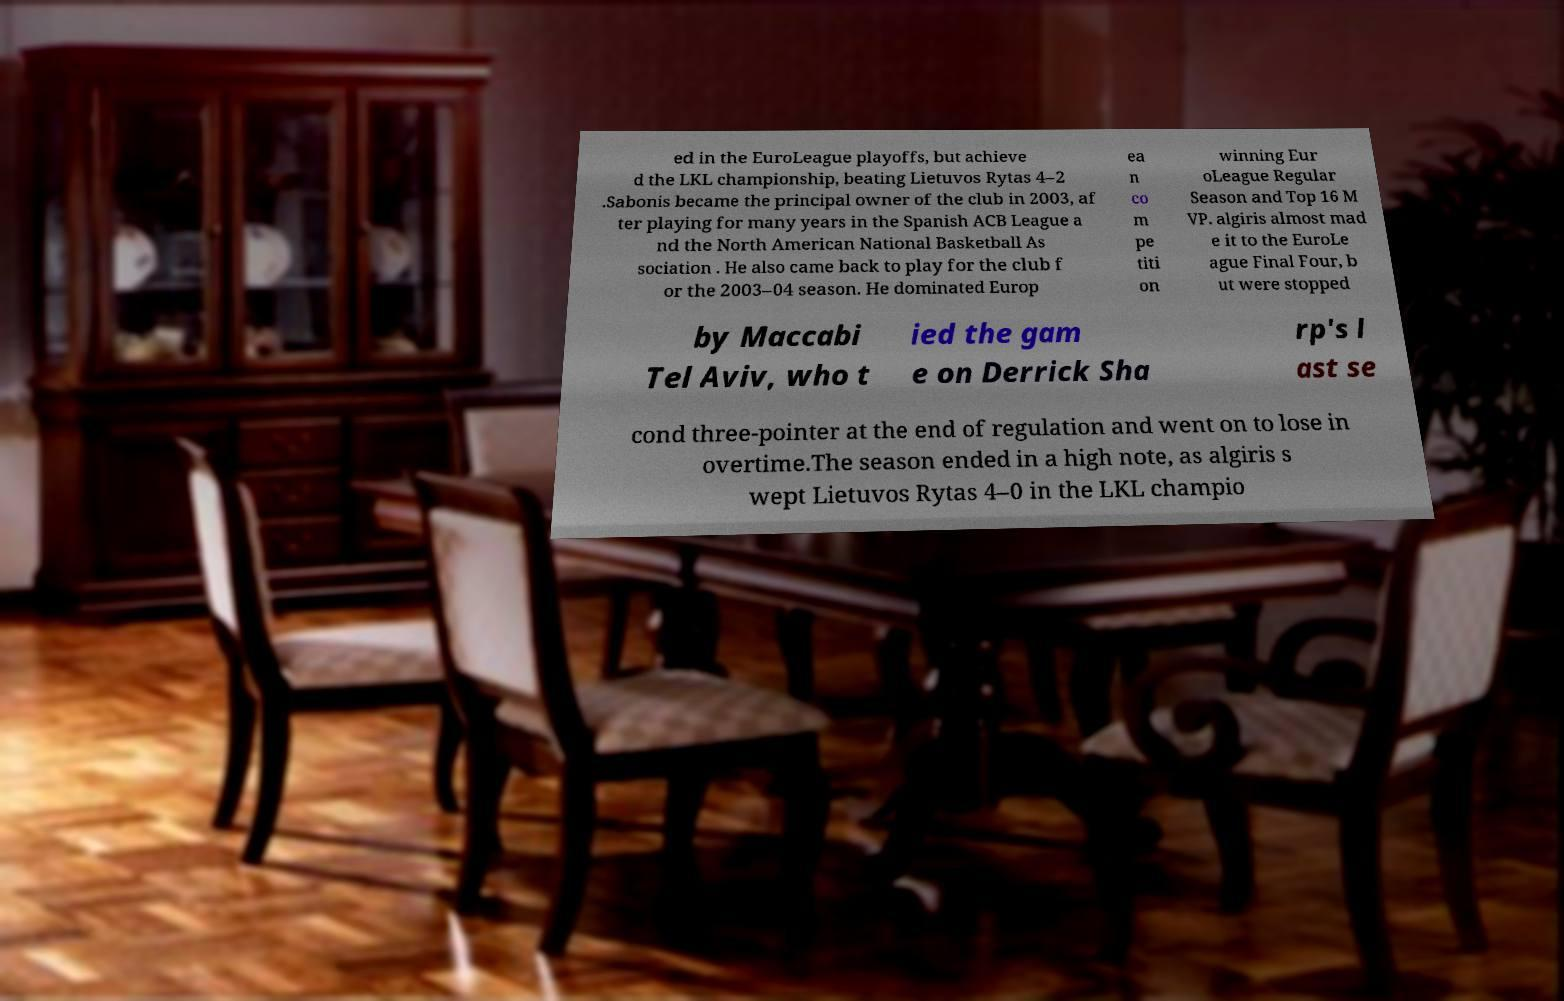Can you accurately transcribe the text from the provided image for me? ed in the EuroLeague playoffs, but achieve d the LKL championship, beating Lietuvos Rytas 4–2 .Sabonis became the principal owner of the club in 2003, af ter playing for many years in the Spanish ACB League a nd the North American National Basketball As sociation . He also came back to play for the club f or the 2003–04 season. He dominated Europ ea n co m pe titi on winning Eur oLeague Regular Season and Top 16 M VP. algiris almost mad e it to the EuroLe ague Final Four, b ut were stopped by Maccabi Tel Aviv, who t ied the gam e on Derrick Sha rp's l ast se cond three-pointer at the end of regulation and went on to lose in overtime.The season ended in a high note, as algiris s wept Lietuvos Rytas 4–0 in the LKL champio 